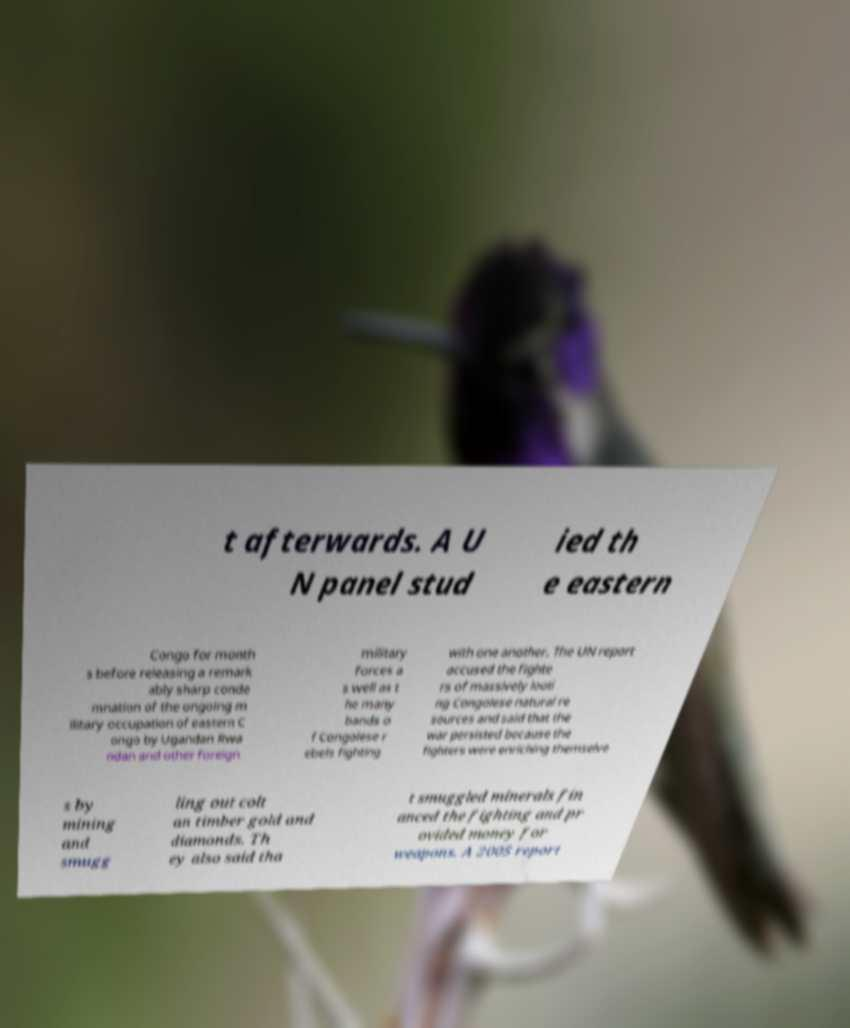There's text embedded in this image that I need extracted. Can you transcribe it verbatim? t afterwards. A U N panel stud ied th e eastern Congo for month s before releasing a remark ably sharp conde mnation of the ongoing m ilitary occupation of eastern C ongo by Ugandan Rwa ndan and other foreign military forces a s well as t he many bands o f Congolese r ebels fighting with one another. The UN report accused the fighte rs of massively looti ng Congolese natural re sources and said that the war persisted because the fighters were enriching themselve s by mining and smugg ling out colt an timber gold and diamonds. Th ey also said tha t smuggled minerals fin anced the fighting and pr ovided money for weapons. A 2005 report 